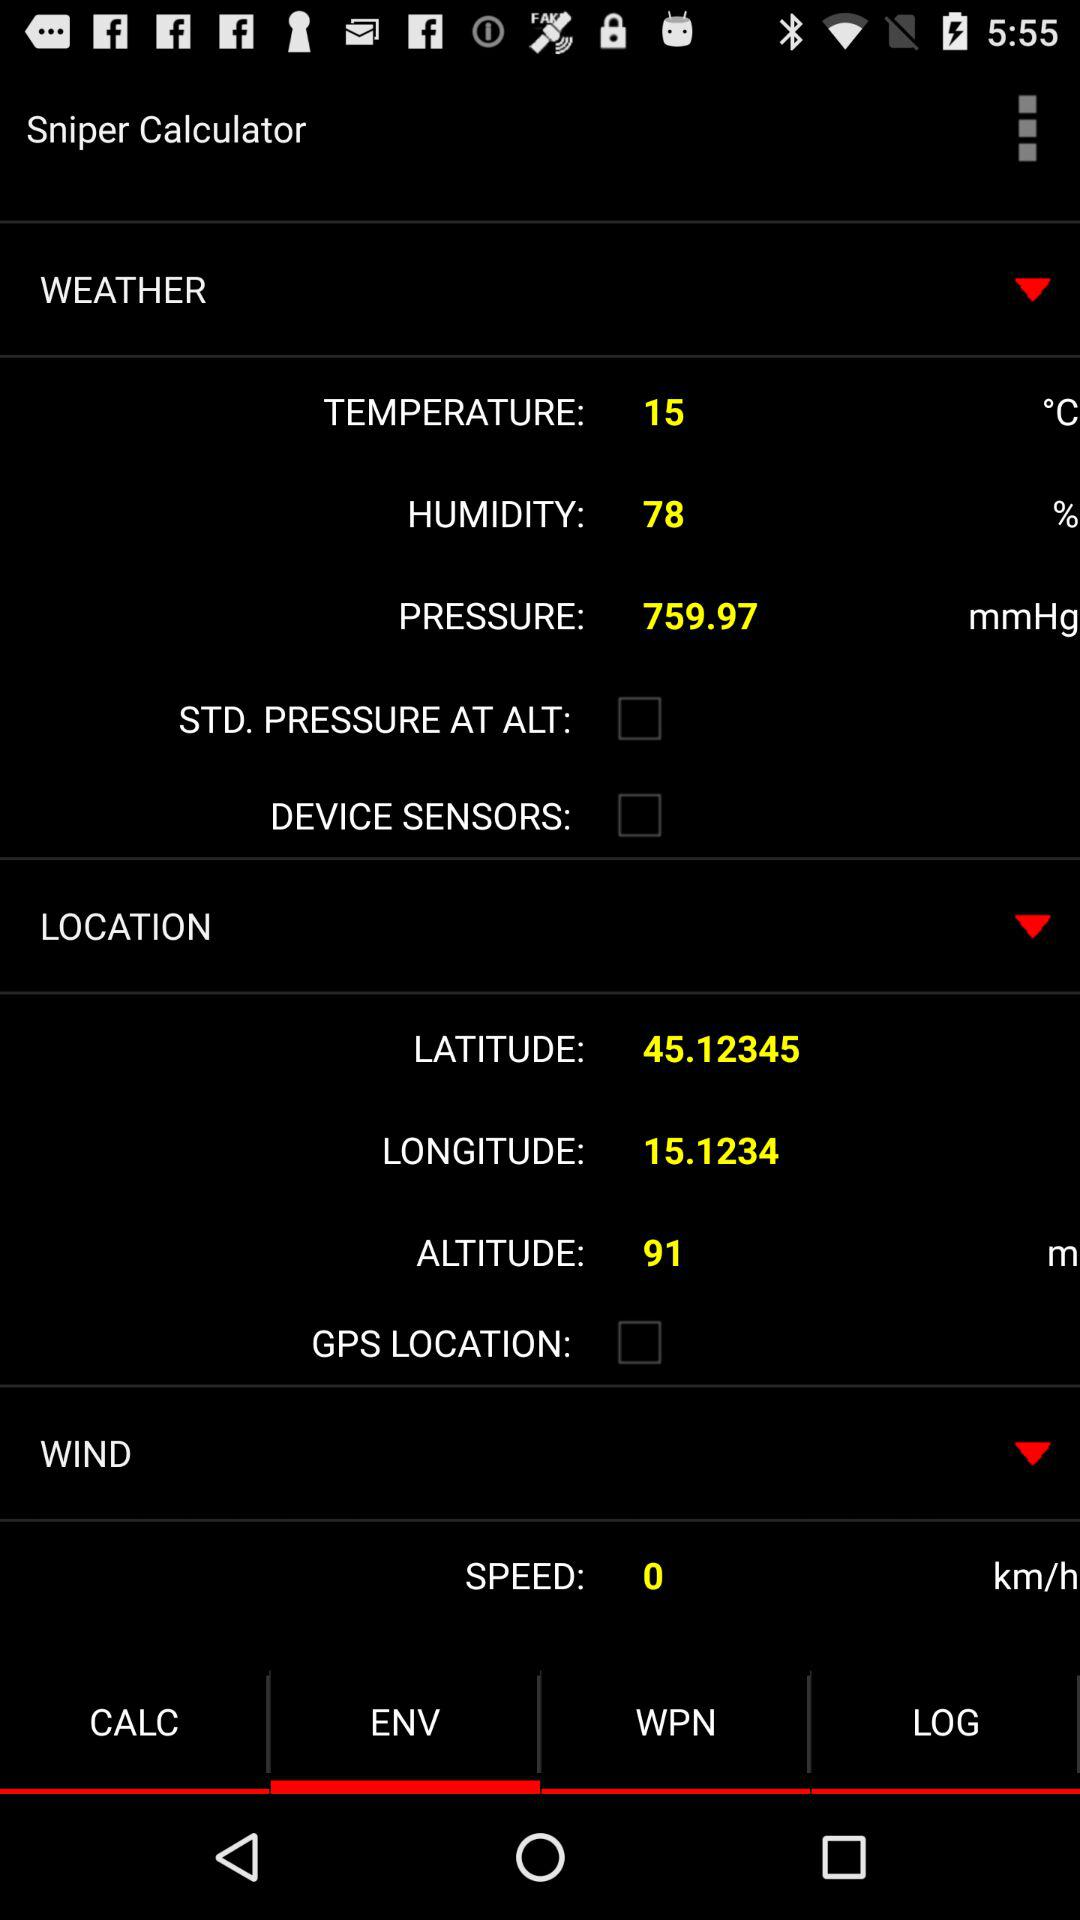What is the pressure? The pressure is 759.97 mmHg. 